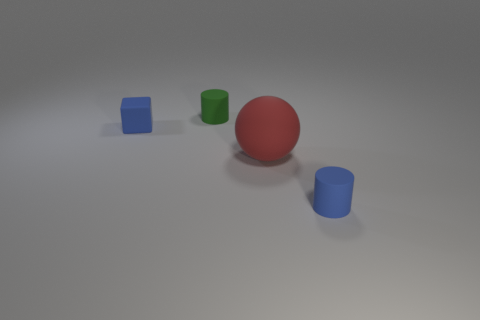Add 2 blue cubes. How many objects exist? 6 Subtract all blocks. How many objects are left? 3 Add 3 rubber cubes. How many rubber cubes are left? 4 Add 3 small things. How many small things exist? 6 Subtract 0 purple cylinders. How many objects are left? 4 Subtract all large red objects. Subtract all cylinders. How many objects are left? 1 